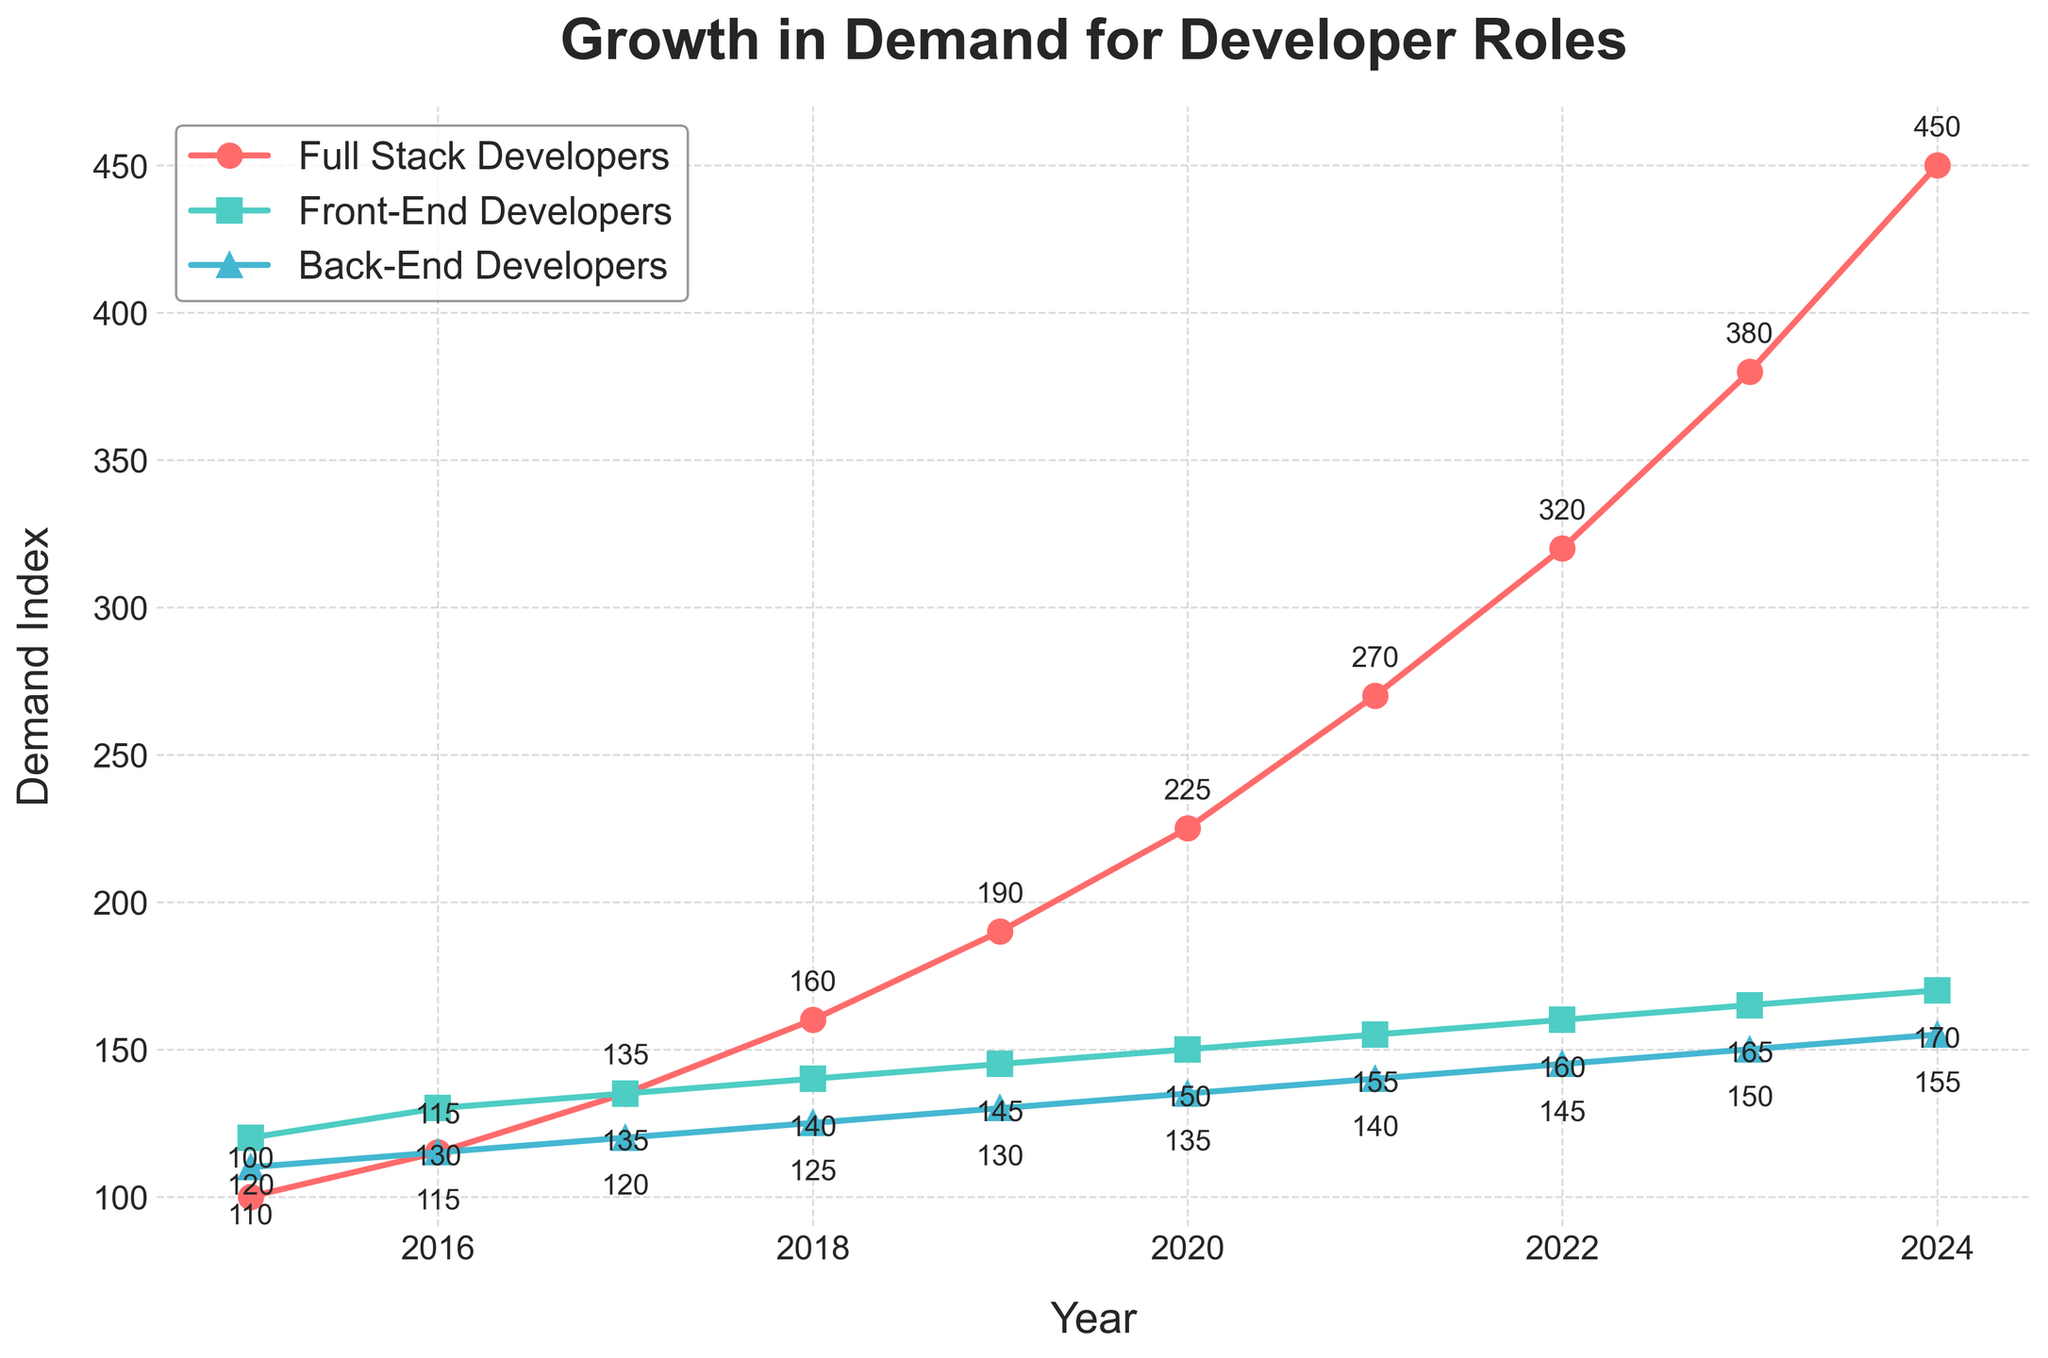How has the demand for Full Stack Developers changed from 2015 to 2024? The plot shows an increasing trend for Full Stack Developers, starting at 100 in 2015 and reaching 450 in 2024. By looking at the overall trajectory, the demand has consistently increased over the years.
Answer: The demand increased from 100 to 450 Which developer role experienced the least growth over the years? By comparing the slopes of the lines representing Full Stack, Front-End, and Back-End Developers, it's clear that the line for Back-End Developers has grown the least, starting at 110 in 2015 and reaching 155 in 2024.
Answer: Back-End Developers What is the difference in demand for Full Stack Developers and Front-End Developers in 2023? The plot shows that in 2023, Full Stack Developers had a demand of 380, and Front-End Developers had a demand of 165. Subtracting these values gives the difference.
Answer: 215 During which year did the demand for Full Stack Developers surpass 200? By examining the line for Full Stack Developers, it is clear that the demand first surpasses 200 in the year 2020 when it reaches 225.
Answer: 2020 By how much did the demand for Back-End Developers change from 2016 to 2022? According to the plot, the demand for Back-End Developers was 115 in 2016 and rose to 145 in 2022. The change is calculated by subtracting 115 from 145.
Answer: 30 Which year had the highest demand differential between Front-End and Back-End Developers? By inspecting the distance between the lines of Front-End and Back-End Developers over the years, we see that the largest difference is in 2015, with Front-End at 120 and Back-End at 110, a differential of 10.
Answer: 2015 What is the trend for the demand for Front-End Developers from 2017 to 2020? The line representing Front-End Developers in the plot shows a steady, albeit slow, increase in demand from 135 in 2017 to 150 in 2020.
Answer: Slow increase What does the steepest incline in the Full Stack Developers' demand occur? The steepest incline can be identified by looking at where the Full Stack Developers line has the most significant rise, which is between 2022 (320) and 2023 (380). The change is 60 units.
Answer: Between 2022 and 2023 When were the demands for all three roles the closest together? Observing the point at which all three lines are visually nearest to each other, the year 2017 appears to have demand values closer to each other with Full Stack at 135, Front-End at 135, and Back-End at 120.
Answer: 2017 What is the percentage increase in demand for Full Stack Developers from 2015 to 2024? First, calculate the absolute increase from 100 in 2015 to 450 in 2024, which is 350. Next, divide by the initial value (100) and multiply by 100 to get the percentage.
Answer: 350% 